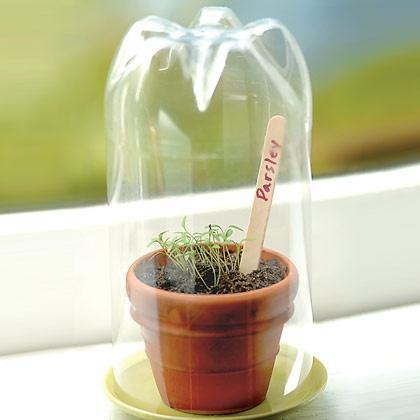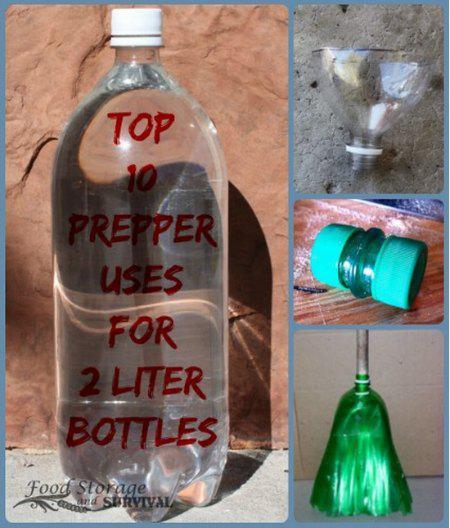The first image is the image on the left, the second image is the image on the right. For the images displayed, is the sentence "One of the bottles contains money bills." factually correct? Answer yes or no. No. The first image is the image on the left, the second image is the image on the right. Given the left and right images, does the statement "Each image contains at least one green soda bottle, and the left image features a bottle with a label that includes jagged shapes and red letters." hold true? Answer yes or no. No. 